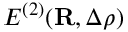<formula> <loc_0><loc_0><loc_500><loc_500>E ^ { ( 2 ) } ( { R } , \Delta \rho )</formula> 